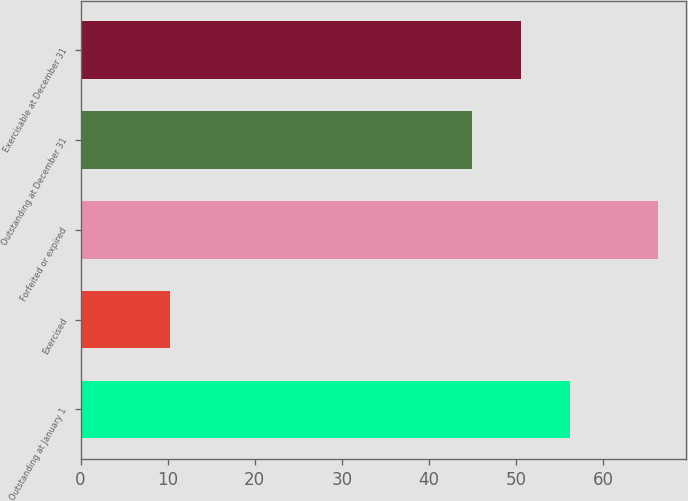Convert chart. <chart><loc_0><loc_0><loc_500><loc_500><bar_chart><fcel>Outstanding at January 1<fcel>Exercised<fcel>Forfeited or expired<fcel>Outstanding at December 31<fcel>Exercisable at December 31<nl><fcel>56.18<fcel>10.32<fcel>66.25<fcel>45<fcel>50.59<nl></chart> 